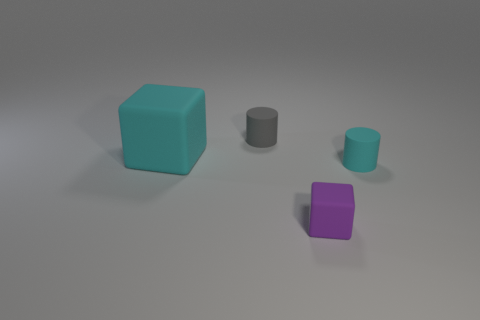Add 3 cyan objects. How many objects exist? 7 Add 4 small matte cubes. How many small matte cubes are left? 5 Add 2 blue objects. How many blue objects exist? 2 Subtract 0 green spheres. How many objects are left? 4 Subtract all tiny purple blocks. Subtract all big matte things. How many objects are left? 2 